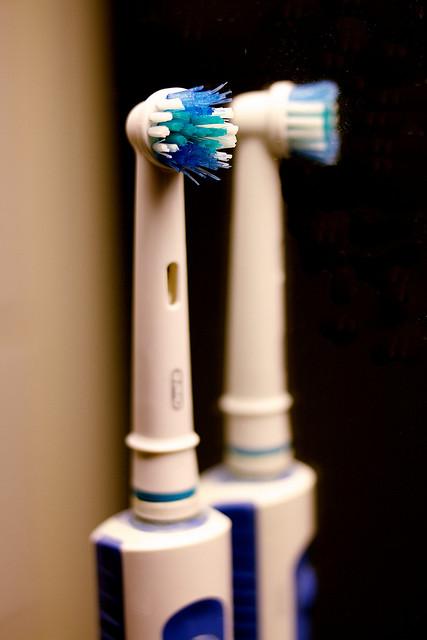What color bristles are in this toothbrush?
Be succinct. Blue. What kind of toothbrush is this?
Give a very brief answer. Electric. Is either toothbrush a reflection?
Give a very brief answer. Yes. 